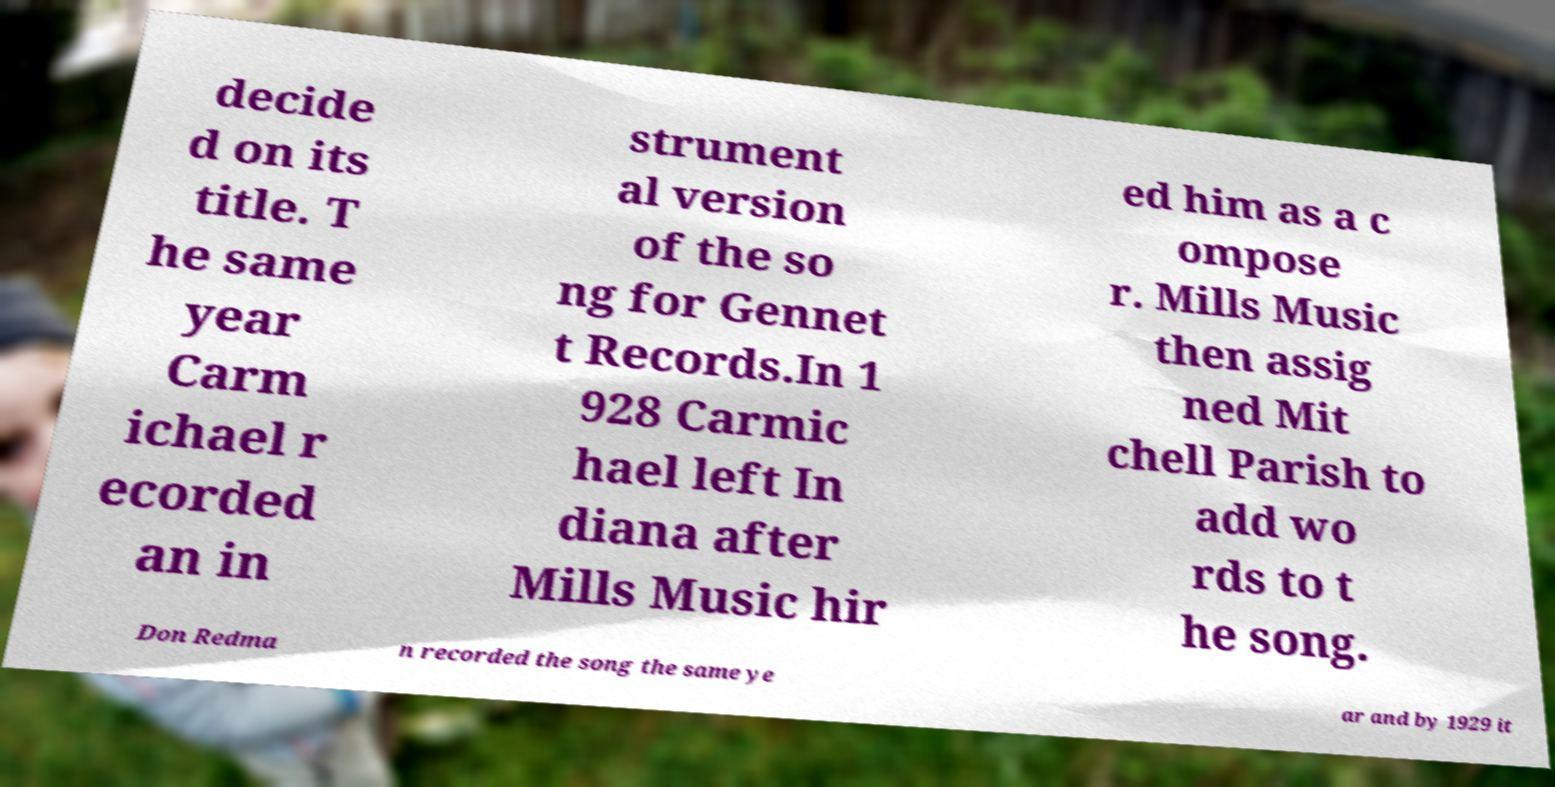For documentation purposes, I need the text within this image transcribed. Could you provide that? decide d on its title. T he same year Carm ichael r ecorded an in strument al version of the so ng for Gennet t Records.In 1 928 Carmic hael left In diana after Mills Music hir ed him as a c ompose r. Mills Music then assig ned Mit chell Parish to add wo rds to t he song. Don Redma n recorded the song the same ye ar and by 1929 it 